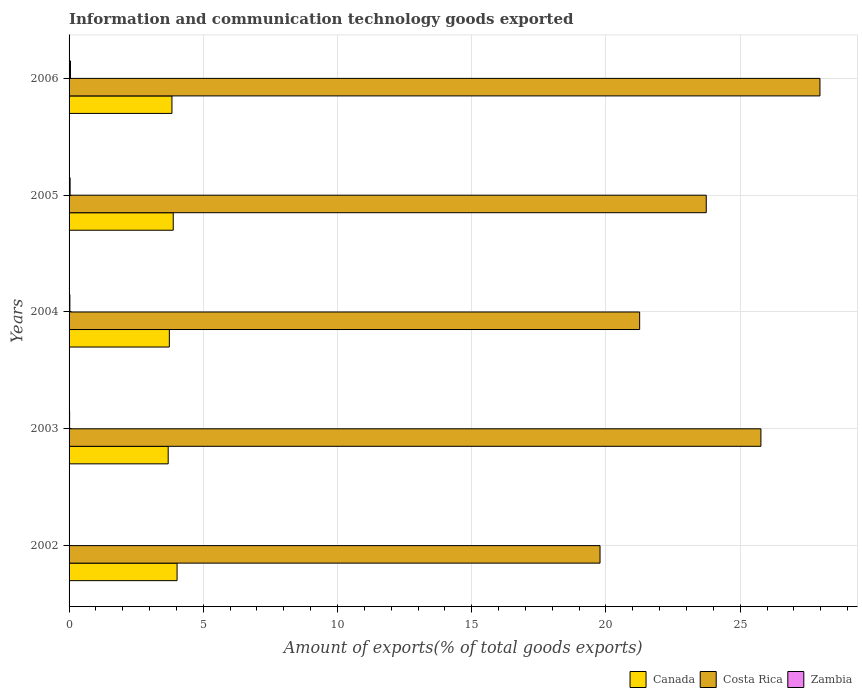How many different coloured bars are there?
Provide a succinct answer. 3. In how many cases, is the number of bars for a given year not equal to the number of legend labels?
Your answer should be very brief. 0. What is the amount of goods exported in Canada in 2006?
Offer a very short reply. 3.83. Across all years, what is the maximum amount of goods exported in Canada?
Offer a very short reply. 4.02. Across all years, what is the minimum amount of goods exported in Costa Rica?
Offer a terse response. 19.78. In which year was the amount of goods exported in Canada maximum?
Give a very brief answer. 2002. In which year was the amount of goods exported in Zambia minimum?
Offer a terse response. 2002. What is the total amount of goods exported in Costa Rica in the graph?
Give a very brief answer. 118.52. What is the difference between the amount of goods exported in Costa Rica in 2003 and that in 2004?
Your response must be concise. 4.52. What is the difference between the amount of goods exported in Zambia in 2004 and the amount of goods exported in Canada in 2006?
Provide a succinct answer. -3.8. What is the average amount of goods exported in Canada per year?
Make the answer very short. 3.83. In the year 2004, what is the difference between the amount of goods exported in Costa Rica and amount of goods exported in Canada?
Your answer should be very brief. 17.52. In how many years, is the amount of goods exported in Costa Rica greater than 19 %?
Offer a terse response. 5. What is the ratio of the amount of goods exported in Canada in 2002 to that in 2003?
Your answer should be compact. 1.09. Is the difference between the amount of goods exported in Costa Rica in 2003 and 2005 greater than the difference between the amount of goods exported in Canada in 2003 and 2005?
Offer a very short reply. Yes. What is the difference between the highest and the second highest amount of goods exported in Zambia?
Make the answer very short. 0.01. What is the difference between the highest and the lowest amount of goods exported in Costa Rica?
Your answer should be very brief. 8.19. In how many years, is the amount of goods exported in Costa Rica greater than the average amount of goods exported in Costa Rica taken over all years?
Your answer should be compact. 3. Is the sum of the amount of goods exported in Canada in 2003 and 2004 greater than the maximum amount of goods exported in Zambia across all years?
Provide a succinct answer. Yes. What does the 3rd bar from the top in 2006 represents?
Ensure brevity in your answer.  Canada. Is it the case that in every year, the sum of the amount of goods exported in Zambia and amount of goods exported in Costa Rica is greater than the amount of goods exported in Canada?
Ensure brevity in your answer.  Yes. How many years are there in the graph?
Make the answer very short. 5. What is the difference between two consecutive major ticks on the X-axis?
Make the answer very short. 5. Are the values on the major ticks of X-axis written in scientific E-notation?
Your answer should be compact. No. Does the graph contain any zero values?
Give a very brief answer. No. How many legend labels are there?
Provide a short and direct response. 3. How are the legend labels stacked?
Your answer should be compact. Horizontal. What is the title of the graph?
Your answer should be very brief. Information and communication technology goods exported. What is the label or title of the X-axis?
Give a very brief answer. Amount of exports(% of total goods exports). What is the label or title of the Y-axis?
Ensure brevity in your answer.  Years. What is the Amount of exports(% of total goods exports) of Canada in 2002?
Make the answer very short. 4.02. What is the Amount of exports(% of total goods exports) of Costa Rica in 2002?
Offer a terse response. 19.78. What is the Amount of exports(% of total goods exports) in Zambia in 2002?
Offer a very short reply. 0.01. What is the Amount of exports(% of total goods exports) in Canada in 2003?
Keep it short and to the point. 3.69. What is the Amount of exports(% of total goods exports) of Costa Rica in 2003?
Keep it short and to the point. 25.77. What is the Amount of exports(% of total goods exports) of Zambia in 2003?
Your answer should be compact. 0.02. What is the Amount of exports(% of total goods exports) of Canada in 2004?
Provide a short and direct response. 3.74. What is the Amount of exports(% of total goods exports) of Costa Rica in 2004?
Your response must be concise. 21.26. What is the Amount of exports(% of total goods exports) in Zambia in 2004?
Make the answer very short. 0.03. What is the Amount of exports(% of total goods exports) in Canada in 2005?
Your response must be concise. 3.88. What is the Amount of exports(% of total goods exports) in Costa Rica in 2005?
Your answer should be very brief. 23.74. What is the Amount of exports(% of total goods exports) in Zambia in 2005?
Ensure brevity in your answer.  0.04. What is the Amount of exports(% of total goods exports) in Canada in 2006?
Provide a succinct answer. 3.83. What is the Amount of exports(% of total goods exports) in Costa Rica in 2006?
Give a very brief answer. 27.97. What is the Amount of exports(% of total goods exports) of Zambia in 2006?
Provide a short and direct response. 0.05. Across all years, what is the maximum Amount of exports(% of total goods exports) of Canada?
Your answer should be compact. 4.02. Across all years, what is the maximum Amount of exports(% of total goods exports) in Costa Rica?
Give a very brief answer. 27.97. Across all years, what is the maximum Amount of exports(% of total goods exports) in Zambia?
Provide a short and direct response. 0.05. Across all years, what is the minimum Amount of exports(% of total goods exports) of Canada?
Keep it short and to the point. 3.69. Across all years, what is the minimum Amount of exports(% of total goods exports) in Costa Rica?
Offer a very short reply. 19.78. Across all years, what is the minimum Amount of exports(% of total goods exports) in Zambia?
Make the answer very short. 0.01. What is the total Amount of exports(% of total goods exports) of Canada in the graph?
Offer a very short reply. 19.16. What is the total Amount of exports(% of total goods exports) of Costa Rica in the graph?
Ensure brevity in your answer.  118.52. What is the total Amount of exports(% of total goods exports) in Zambia in the graph?
Provide a succinct answer. 0.15. What is the difference between the Amount of exports(% of total goods exports) of Canada in 2002 and that in 2003?
Your answer should be compact. 0.33. What is the difference between the Amount of exports(% of total goods exports) in Costa Rica in 2002 and that in 2003?
Offer a terse response. -5.99. What is the difference between the Amount of exports(% of total goods exports) in Zambia in 2002 and that in 2003?
Provide a succinct answer. -0.01. What is the difference between the Amount of exports(% of total goods exports) of Canada in 2002 and that in 2004?
Give a very brief answer. 0.29. What is the difference between the Amount of exports(% of total goods exports) in Costa Rica in 2002 and that in 2004?
Provide a short and direct response. -1.48. What is the difference between the Amount of exports(% of total goods exports) of Zambia in 2002 and that in 2004?
Your answer should be very brief. -0.02. What is the difference between the Amount of exports(% of total goods exports) of Canada in 2002 and that in 2005?
Give a very brief answer. 0.14. What is the difference between the Amount of exports(% of total goods exports) of Costa Rica in 2002 and that in 2005?
Your answer should be compact. -3.96. What is the difference between the Amount of exports(% of total goods exports) in Zambia in 2002 and that in 2005?
Your answer should be very brief. -0.03. What is the difference between the Amount of exports(% of total goods exports) of Canada in 2002 and that in 2006?
Keep it short and to the point. 0.19. What is the difference between the Amount of exports(% of total goods exports) in Costa Rica in 2002 and that in 2006?
Give a very brief answer. -8.19. What is the difference between the Amount of exports(% of total goods exports) of Zambia in 2002 and that in 2006?
Your answer should be very brief. -0.04. What is the difference between the Amount of exports(% of total goods exports) in Canada in 2003 and that in 2004?
Offer a very short reply. -0.04. What is the difference between the Amount of exports(% of total goods exports) in Costa Rica in 2003 and that in 2004?
Make the answer very short. 4.52. What is the difference between the Amount of exports(% of total goods exports) of Zambia in 2003 and that in 2004?
Your answer should be compact. -0.01. What is the difference between the Amount of exports(% of total goods exports) of Canada in 2003 and that in 2005?
Keep it short and to the point. -0.19. What is the difference between the Amount of exports(% of total goods exports) in Costa Rica in 2003 and that in 2005?
Offer a terse response. 2.04. What is the difference between the Amount of exports(% of total goods exports) of Zambia in 2003 and that in 2005?
Offer a very short reply. -0.02. What is the difference between the Amount of exports(% of total goods exports) in Canada in 2003 and that in 2006?
Ensure brevity in your answer.  -0.14. What is the difference between the Amount of exports(% of total goods exports) of Costa Rica in 2003 and that in 2006?
Provide a succinct answer. -2.2. What is the difference between the Amount of exports(% of total goods exports) of Zambia in 2003 and that in 2006?
Make the answer very short. -0.03. What is the difference between the Amount of exports(% of total goods exports) in Canada in 2004 and that in 2005?
Your answer should be very brief. -0.14. What is the difference between the Amount of exports(% of total goods exports) of Costa Rica in 2004 and that in 2005?
Provide a succinct answer. -2.48. What is the difference between the Amount of exports(% of total goods exports) in Zambia in 2004 and that in 2005?
Keep it short and to the point. -0.01. What is the difference between the Amount of exports(% of total goods exports) in Canada in 2004 and that in 2006?
Offer a very short reply. -0.1. What is the difference between the Amount of exports(% of total goods exports) in Costa Rica in 2004 and that in 2006?
Give a very brief answer. -6.72. What is the difference between the Amount of exports(% of total goods exports) of Zambia in 2004 and that in 2006?
Give a very brief answer. -0.02. What is the difference between the Amount of exports(% of total goods exports) of Canada in 2005 and that in 2006?
Provide a short and direct response. 0.05. What is the difference between the Amount of exports(% of total goods exports) in Costa Rica in 2005 and that in 2006?
Make the answer very short. -4.24. What is the difference between the Amount of exports(% of total goods exports) of Zambia in 2005 and that in 2006?
Your response must be concise. -0.01. What is the difference between the Amount of exports(% of total goods exports) of Canada in 2002 and the Amount of exports(% of total goods exports) of Costa Rica in 2003?
Provide a short and direct response. -21.75. What is the difference between the Amount of exports(% of total goods exports) in Canada in 2002 and the Amount of exports(% of total goods exports) in Zambia in 2003?
Provide a succinct answer. 4. What is the difference between the Amount of exports(% of total goods exports) in Costa Rica in 2002 and the Amount of exports(% of total goods exports) in Zambia in 2003?
Offer a very short reply. 19.76. What is the difference between the Amount of exports(% of total goods exports) in Canada in 2002 and the Amount of exports(% of total goods exports) in Costa Rica in 2004?
Offer a terse response. -17.23. What is the difference between the Amount of exports(% of total goods exports) of Canada in 2002 and the Amount of exports(% of total goods exports) of Zambia in 2004?
Ensure brevity in your answer.  3.99. What is the difference between the Amount of exports(% of total goods exports) in Costa Rica in 2002 and the Amount of exports(% of total goods exports) in Zambia in 2004?
Provide a succinct answer. 19.75. What is the difference between the Amount of exports(% of total goods exports) of Canada in 2002 and the Amount of exports(% of total goods exports) of Costa Rica in 2005?
Your answer should be very brief. -19.71. What is the difference between the Amount of exports(% of total goods exports) of Canada in 2002 and the Amount of exports(% of total goods exports) of Zambia in 2005?
Ensure brevity in your answer.  3.98. What is the difference between the Amount of exports(% of total goods exports) of Costa Rica in 2002 and the Amount of exports(% of total goods exports) of Zambia in 2005?
Your answer should be very brief. 19.74. What is the difference between the Amount of exports(% of total goods exports) of Canada in 2002 and the Amount of exports(% of total goods exports) of Costa Rica in 2006?
Provide a succinct answer. -23.95. What is the difference between the Amount of exports(% of total goods exports) in Canada in 2002 and the Amount of exports(% of total goods exports) in Zambia in 2006?
Ensure brevity in your answer.  3.97. What is the difference between the Amount of exports(% of total goods exports) in Costa Rica in 2002 and the Amount of exports(% of total goods exports) in Zambia in 2006?
Provide a short and direct response. 19.73. What is the difference between the Amount of exports(% of total goods exports) of Canada in 2003 and the Amount of exports(% of total goods exports) of Costa Rica in 2004?
Your response must be concise. -17.56. What is the difference between the Amount of exports(% of total goods exports) in Canada in 2003 and the Amount of exports(% of total goods exports) in Zambia in 2004?
Give a very brief answer. 3.66. What is the difference between the Amount of exports(% of total goods exports) of Costa Rica in 2003 and the Amount of exports(% of total goods exports) of Zambia in 2004?
Ensure brevity in your answer.  25.74. What is the difference between the Amount of exports(% of total goods exports) in Canada in 2003 and the Amount of exports(% of total goods exports) in Costa Rica in 2005?
Keep it short and to the point. -20.04. What is the difference between the Amount of exports(% of total goods exports) of Canada in 2003 and the Amount of exports(% of total goods exports) of Zambia in 2005?
Provide a succinct answer. 3.65. What is the difference between the Amount of exports(% of total goods exports) in Costa Rica in 2003 and the Amount of exports(% of total goods exports) in Zambia in 2005?
Your answer should be very brief. 25.73. What is the difference between the Amount of exports(% of total goods exports) in Canada in 2003 and the Amount of exports(% of total goods exports) in Costa Rica in 2006?
Give a very brief answer. -24.28. What is the difference between the Amount of exports(% of total goods exports) of Canada in 2003 and the Amount of exports(% of total goods exports) of Zambia in 2006?
Your answer should be very brief. 3.64. What is the difference between the Amount of exports(% of total goods exports) of Costa Rica in 2003 and the Amount of exports(% of total goods exports) of Zambia in 2006?
Your answer should be very brief. 25.72. What is the difference between the Amount of exports(% of total goods exports) of Canada in 2004 and the Amount of exports(% of total goods exports) of Costa Rica in 2005?
Make the answer very short. -20. What is the difference between the Amount of exports(% of total goods exports) in Canada in 2004 and the Amount of exports(% of total goods exports) in Zambia in 2005?
Offer a terse response. 3.7. What is the difference between the Amount of exports(% of total goods exports) in Costa Rica in 2004 and the Amount of exports(% of total goods exports) in Zambia in 2005?
Your answer should be compact. 21.22. What is the difference between the Amount of exports(% of total goods exports) in Canada in 2004 and the Amount of exports(% of total goods exports) in Costa Rica in 2006?
Your response must be concise. -24.24. What is the difference between the Amount of exports(% of total goods exports) in Canada in 2004 and the Amount of exports(% of total goods exports) in Zambia in 2006?
Your response must be concise. 3.68. What is the difference between the Amount of exports(% of total goods exports) in Costa Rica in 2004 and the Amount of exports(% of total goods exports) in Zambia in 2006?
Provide a short and direct response. 21.2. What is the difference between the Amount of exports(% of total goods exports) of Canada in 2005 and the Amount of exports(% of total goods exports) of Costa Rica in 2006?
Ensure brevity in your answer.  -24.09. What is the difference between the Amount of exports(% of total goods exports) in Canada in 2005 and the Amount of exports(% of total goods exports) in Zambia in 2006?
Your response must be concise. 3.83. What is the difference between the Amount of exports(% of total goods exports) in Costa Rica in 2005 and the Amount of exports(% of total goods exports) in Zambia in 2006?
Your answer should be very brief. 23.68. What is the average Amount of exports(% of total goods exports) of Canada per year?
Ensure brevity in your answer.  3.83. What is the average Amount of exports(% of total goods exports) of Costa Rica per year?
Your answer should be very brief. 23.7. What is the average Amount of exports(% of total goods exports) in Zambia per year?
Your response must be concise. 0.03. In the year 2002, what is the difference between the Amount of exports(% of total goods exports) of Canada and Amount of exports(% of total goods exports) of Costa Rica?
Your answer should be very brief. -15.76. In the year 2002, what is the difference between the Amount of exports(% of total goods exports) of Canada and Amount of exports(% of total goods exports) of Zambia?
Your answer should be very brief. 4.01. In the year 2002, what is the difference between the Amount of exports(% of total goods exports) in Costa Rica and Amount of exports(% of total goods exports) in Zambia?
Provide a short and direct response. 19.77. In the year 2003, what is the difference between the Amount of exports(% of total goods exports) in Canada and Amount of exports(% of total goods exports) in Costa Rica?
Provide a succinct answer. -22.08. In the year 2003, what is the difference between the Amount of exports(% of total goods exports) of Canada and Amount of exports(% of total goods exports) of Zambia?
Make the answer very short. 3.67. In the year 2003, what is the difference between the Amount of exports(% of total goods exports) of Costa Rica and Amount of exports(% of total goods exports) of Zambia?
Your answer should be very brief. 25.75. In the year 2004, what is the difference between the Amount of exports(% of total goods exports) of Canada and Amount of exports(% of total goods exports) of Costa Rica?
Your response must be concise. -17.52. In the year 2004, what is the difference between the Amount of exports(% of total goods exports) of Canada and Amount of exports(% of total goods exports) of Zambia?
Offer a very short reply. 3.71. In the year 2004, what is the difference between the Amount of exports(% of total goods exports) of Costa Rica and Amount of exports(% of total goods exports) of Zambia?
Keep it short and to the point. 21.23. In the year 2005, what is the difference between the Amount of exports(% of total goods exports) of Canada and Amount of exports(% of total goods exports) of Costa Rica?
Keep it short and to the point. -19.86. In the year 2005, what is the difference between the Amount of exports(% of total goods exports) in Canada and Amount of exports(% of total goods exports) in Zambia?
Your answer should be compact. 3.84. In the year 2005, what is the difference between the Amount of exports(% of total goods exports) of Costa Rica and Amount of exports(% of total goods exports) of Zambia?
Provide a short and direct response. 23.7. In the year 2006, what is the difference between the Amount of exports(% of total goods exports) in Canada and Amount of exports(% of total goods exports) in Costa Rica?
Provide a succinct answer. -24.14. In the year 2006, what is the difference between the Amount of exports(% of total goods exports) of Canada and Amount of exports(% of total goods exports) of Zambia?
Make the answer very short. 3.78. In the year 2006, what is the difference between the Amount of exports(% of total goods exports) of Costa Rica and Amount of exports(% of total goods exports) of Zambia?
Your response must be concise. 27.92. What is the ratio of the Amount of exports(% of total goods exports) of Canada in 2002 to that in 2003?
Offer a terse response. 1.09. What is the ratio of the Amount of exports(% of total goods exports) in Costa Rica in 2002 to that in 2003?
Ensure brevity in your answer.  0.77. What is the ratio of the Amount of exports(% of total goods exports) of Zambia in 2002 to that in 2003?
Keep it short and to the point. 0.5. What is the ratio of the Amount of exports(% of total goods exports) of Canada in 2002 to that in 2004?
Give a very brief answer. 1.08. What is the ratio of the Amount of exports(% of total goods exports) of Costa Rica in 2002 to that in 2004?
Give a very brief answer. 0.93. What is the ratio of the Amount of exports(% of total goods exports) of Zambia in 2002 to that in 2004?
Offer a very short reply. 0.33. What is the ratio of the Amount of exports(% of total goods exports) in Costa Rica in 2002 to that in 2005?
Provide a short and direct response. 0.83. What is the ratio of the Amount of exports(% of total goods exports) of Zambia in 2002 to that in 2005?
Offer a very short reply. 0.26. What is the ratio of the Amount of exports(% of total goods exports) in Canada in 2002 to that in 2006?
Make the answer very short. 1.05. What is the ratio of the Amount of exports(% of total goods exports) in Costa Rica in 2002 to that in 2006?
Provide a short and direct response. 0.71. What is the ratio of the Amount of exports(% of total goods exports) in Zambia in 2002 to that in 2006?
Give a very brief answer. 0.19. What is the ratio of the Amount of exports(% of total goods exports) in Costa Rica in 2003 to that in 2004?
Your answer should be very brief. 1.21. What is the ratio of the Amount of exports(% of total goods exports) in Zambia in 2003 to that in 2004?
Give a very brief answer. 0.67. What is the ratio of the Amount of exports(% of total goods exports) in Canada in 2003 to that in 2005?
Offer a very short reply. 0.95. What is the ratio of the Amount of exports(% of total goods exports) in Costa Rica in 2003 to that in 2005?
Your answer should be very brief. 1.09. What is the ratio of the Amount of exports(% of total goods exports) of Zambia in 2003 to that in 2005?
Make the answer very short. 0.51. What is the ratio of the Amount of exports(% of total goods exports) of Canada in 2003 to that in 2006?
Your answer should be very brief. 0.96. What is the ratio of the Amount of exports(% of total goods exports) in Costa Rica in 2003 to that in 2006?
Your response must be concise. 0.92. What is the ratio of the Amount of exports(% of total goods exports) in Zambia in 2003 to that in 2006?
Offer a very short reply. 0.38. What is the ratio of the Amount of exports(% of total goods exports) of Canada in 2004 to that in 2005?
Keep it short and to the point. 0.96. What is the ratio of the Amount of exports(% of total goods exports) in Costa Rica in 2004 to that in 2005?
Provide a short and direct response. 0.9. What is the ratio of the Amount of exports(% of total goods exports) in Zambia in 2004 to that in 2005?
Give a very brief answer. 0.77. What is the ratio of the Amount of exports(% of total goods exports) in Canada in 2004 to that in 2006?
Ensure brevity in your answer.  0.97. What is the ratio of the Amount of exports(% of total goods exports) of Costa Rica in 2004 to that in 2006?
Your answer should be very brief. 0.76. What is the ratio of the Amount of exports(% of total goods exports) in Zambia in 2004 to that in 2006?
Offer a very short reply. 0.57. What is the ratio of the Amount of exports(% of total goods exports) of Canada in 2005 to that in 2006?
Your answer should be compact. 1.01. What is the ratio of the Amount of exports(% of total goods exports) in Costa Rica in 2005 to that in 2006?
Offer a very short reply. 0.85. What is the ratio of the Amount of exports(% of total goods exports) of Zambia in 2005 to that in 2006?
Give a very brief answer. 0.74. What is the difference between the highest and the second highest Amount of exports(% of total goods exports) in Canada?
Make the answer very short. 0.14. What is the difference between the highest and the second highest Amount of exports(% of total goods exports) of Costa Rica?
Your answer should be compact. 2.2. What is the difference between the highest and the second highest Amount of exports(% of total goods exports) in Zambia?
Make the answer very short. 0.01. What is the difference between the highest and the lowest Amount of exports(% of total goods exports) in Canada?
Your answer should be very brief. 0.33. What is the difference between the highest and the lowest Amount of exports(% of total goods exports) in Costa Rica?
Make the answer very short. 8.19. What is the difference between the highest and the lowest Amount of exports(% of total goods exports) of Zambia?
Offer a very short reply. 0.04. 